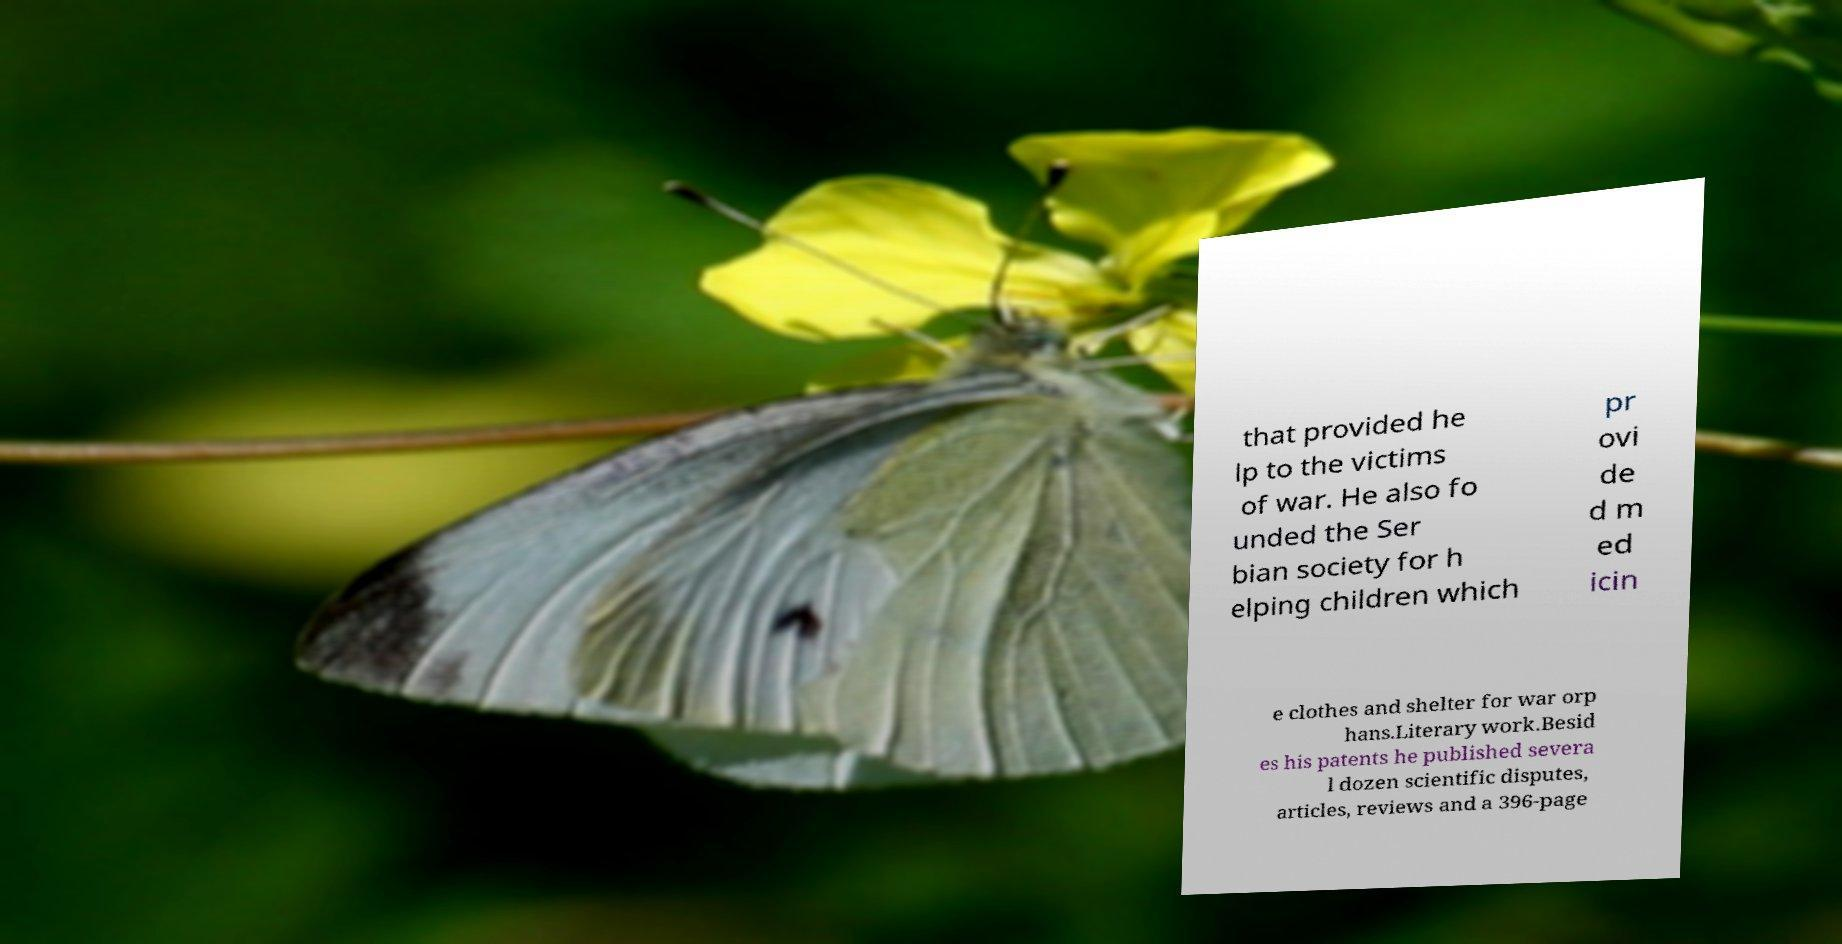Could you extract and type out the text from this image? that provided he lp to the victims of war. He also fo unded the Ser bian society for h elping children which pr ovi de d m ed icin e clothes and shelter for war orp hans.Literary work.Besid es his patents he published severa l dozen scientific disputes, articles, reviews and a 396-page 